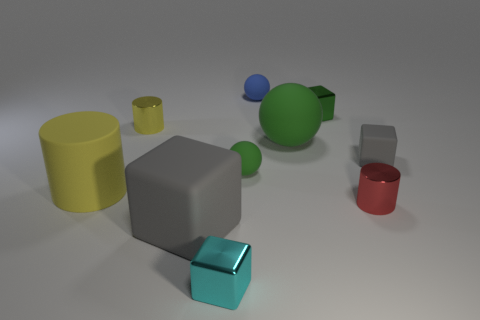Subtract all yellow cylinders. How many were subtracted if there are1yellow cylinders left? 1 Subtract all spheres. How many objects are left? 7 Add 4 large spheres. How many large spheres are left? 5 Add 6 large matte things. How many large matte things exist? 9 Subtract 0 brown balls. How many objects are left? 10 Subtract all small red rubber cylinders. Subtract all green blocks. How many objects are left? 9 